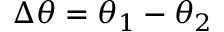Convert formula to latex. <formula><loc_0><loc_0><loc_500><loc_500>\Delta \theta = \theta _ { 1 } - \theta _ { 2 }</formula> 